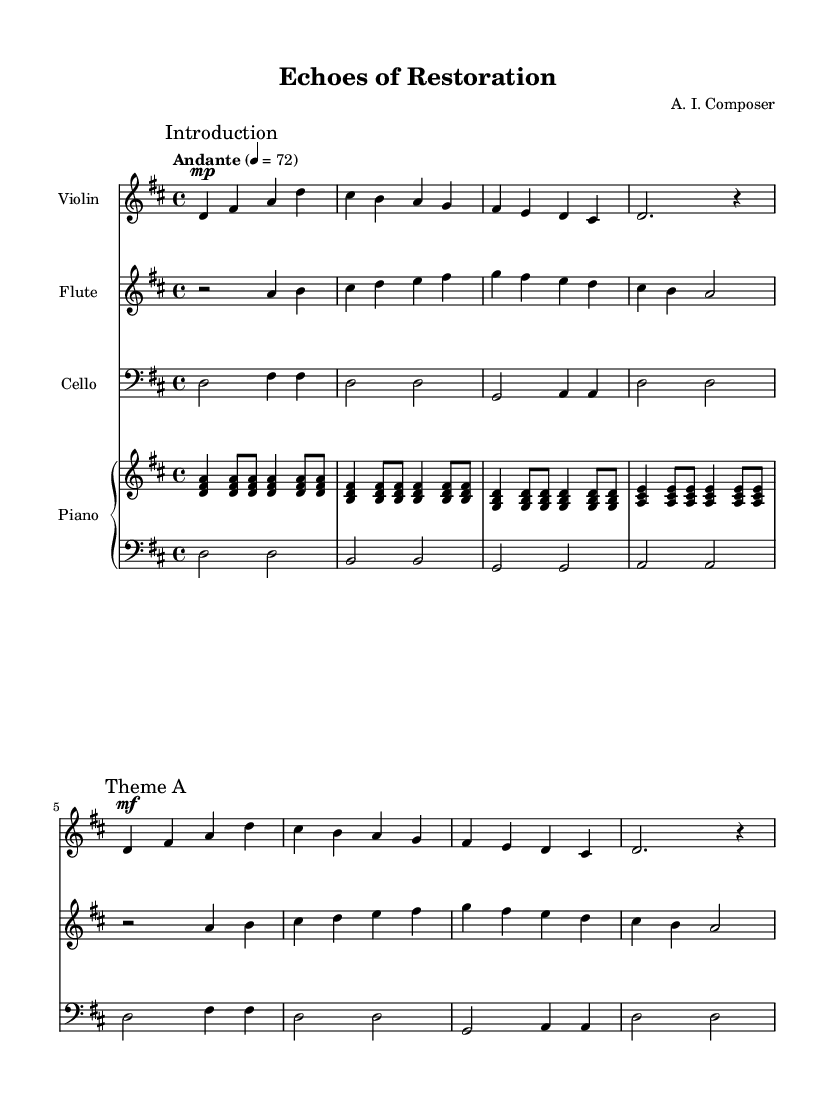What is the key signature of this music? The key signature of the music is D major, which has two sharps: F sharp and C sharp. This is indicated at the beginning of the score.
Answer: D major What is the time signature of this composition? The time signature is 4/4, which means there are four beats in each measure, and the quarter note gets one beat. This is displayed at the beginning of the score.
Answer: 4/4 What tempo marking is given for this piece? The tempo marking is "Andante," indicating a moderately slow pace. The metronome marking provided is 72 beats per minute, setting the speed for the performance.
Answer: Andante How many measures are present in the violin part? The violin part consists of 5 measures as indicated by the grouping of notes before the ending double bar line. Counting each segment from the beginning to the end gives a total of 5.
Answer: 5 Which instruments are included in this score? The score features four instruments: Violin, Flute, Cello, and Piano. Each instrument is listed at the beginning of its respective staff, making them easily identifiable.
Answer: Violin, Flute, Cello, Piano What dynamic marking is indicated at the beginning of the flute part? The dynamic marking at the beginning of the flute part is a rest, represented by the "r" symbol, signifying a pause before the flute enters. This is the first symbol noted after the global key and time signature.
Answer: Rest 